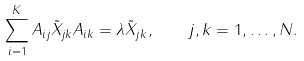Convert formula to latex. <formula><loc_0><loc_0><loc_500><loc_500>\sum _ { i = 1 } ^ { K } A _ { i j } \tilde { X } _ { j k } A _ { i k } = \lambda \tilde { X } _ { j k } , \quad j , k = 1 , \dots , N .</formula> 